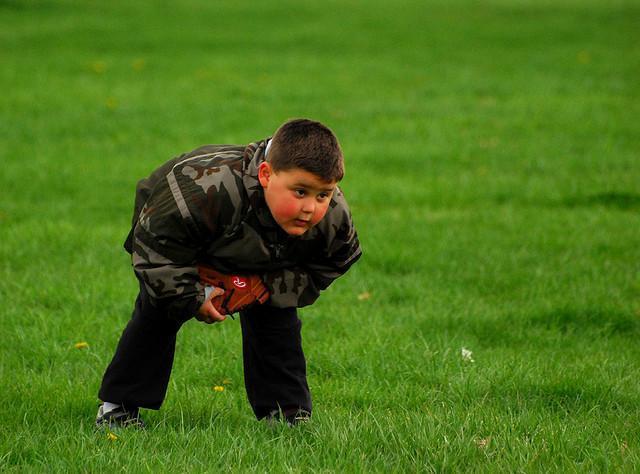How many people are in the picture?
Give a very brief answer. 1. How many clock faces are there?
Give a very brief answer. 0. 